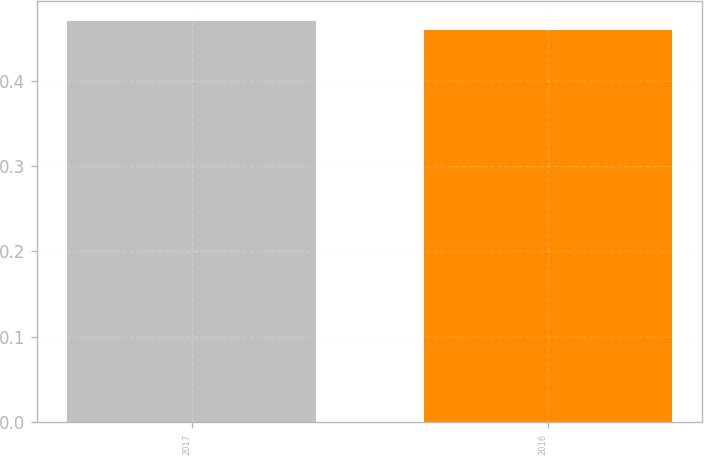<chart> <loc_0><loc_0><loc_500><loc_500><bar_chart><fcel>2017<fcel>2016<nl><fcel>0.47<fcel>0.46<nl></chart> 